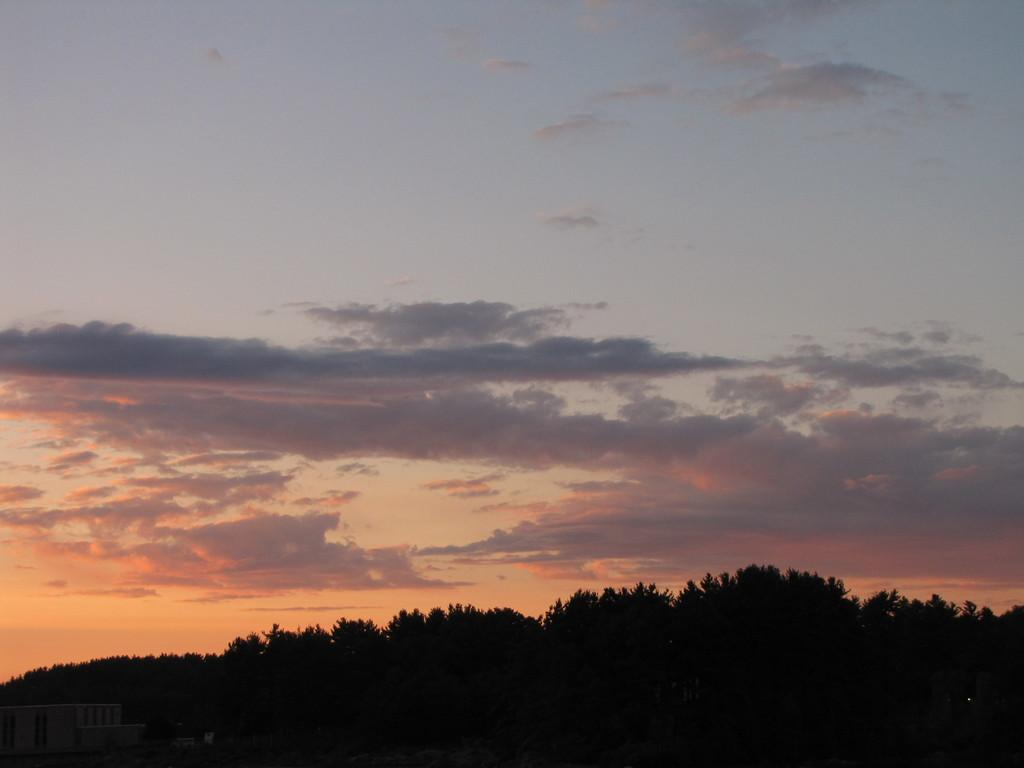What type of structures can be seen in the image? There are houses in the image. What other natural elements are present in the image? There are trees in the image. How would you describe the weather in the image? The sky is cloudy in the image. What type of books can be seen on the bun in the image? There are no books or buns present in the image; it features houses and trees with a cloudy sky. 